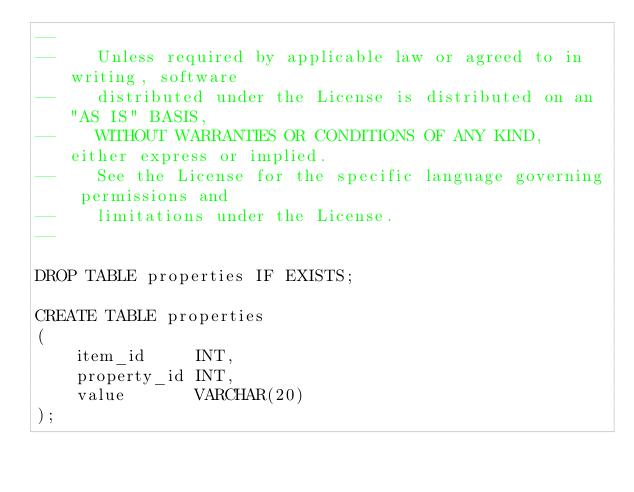Convert code to text. <code><loc_0><loc_0><loc_500><loc_500><_SQL_>--
--    Unless required by applicable law or agreed to in writing, software
--    distributed under the License is distributed on an "AS IS" BASIS,
--    WITHOUT WARRANTIES OR CONDITIONS OF ANY KIND, either express or implied.
--    See the License for the specific language governing permissions and
--    limitations under the License.
--

DROP TABLE properties IF EXISTS;

CREATE TABLE properties
(
    item_id     INT,
    property_id INT,
    value       VARCHAR(20)
);
</code> 